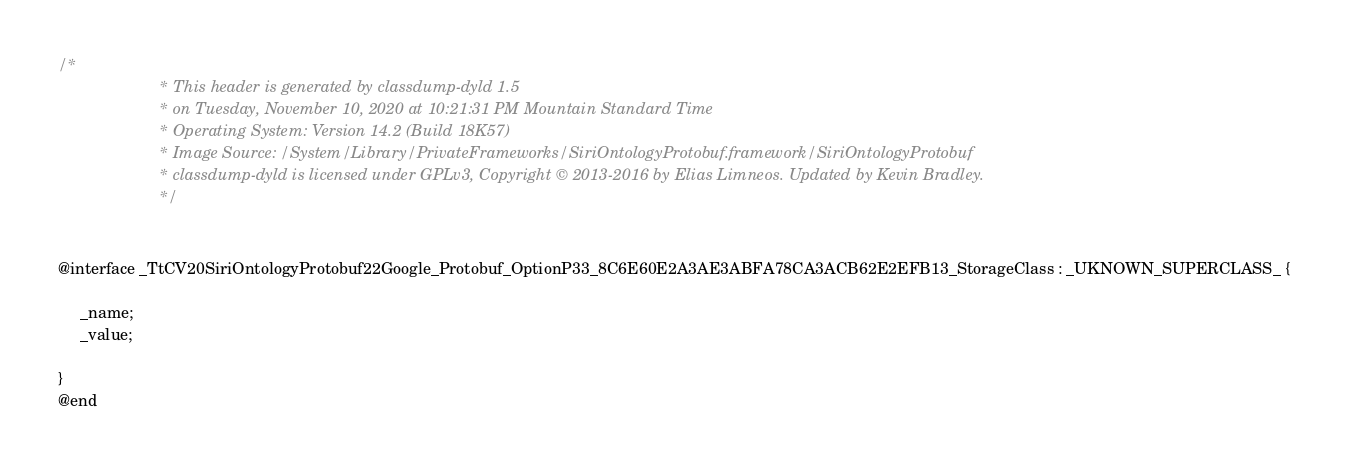Convert code to text. <code><loc_0><loc_0><loc_500><loc_500><_C_>/*
                       * This header is generated by classdump-dyld 1.5
                       * on Tuesday, November 10, 2020 at 10:21:31 PM Mountain Standard Time
                       * Operating System: Version 14.2 (Build 18K57)
                       * Image Source: /System/Library/PrivateFrameworks/SiriOntologyProtobuf.framework/SiriOntologyProtobuf
                       * classdump-dyld is licensed under GPLv3, Copyright © 2013-2016 by Elias Limneos. Updated by Kevin Bradley.
                       */


@interface _TtCV20SiriOntologyProtobuf22Google_Protobuf_OptionP33_8C6E60E2A3AE3ABFA78CA3ACB62E2EFB13_StorageClass : _UKNOWN_SUPERCLASS_ {

	 _name;
	 _value;

}
@end

</code> 